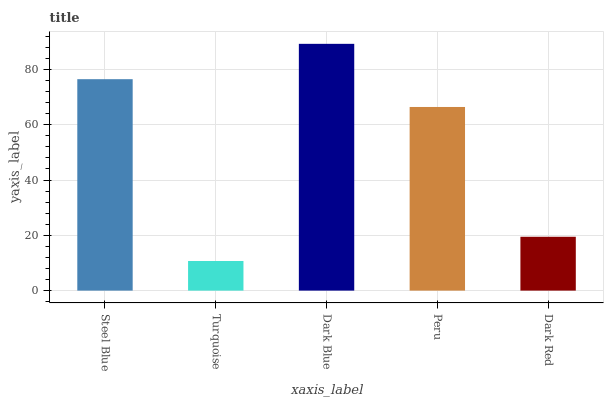Is Turquoise the minimum?
Answer yes or no. Yes. Is Dark Blue the maximum?
Answer yes or no. Yes. Is Dark Blue the minimum?
Answer yes or no. No. Is Turquoise the maximum?
Answer yes or no. No. Is Dark Blue greater than Turquoise?
Answer yes or no. Yes. Is Turquoise less than Dark Blue?
Answer yes or no. Yes. Is Turquoise greater than Dark Blue?
Answer yes or no. No. Is Dark Blue less than Turquoise?
Answer yes or no. No. Is Peru the high median?
Answer yes or no. Yes. Is Peru the low median?
Answer yes or no. Yes. Is Turquoise the high median?
Answer yes or no. No. Is Dark Blue the low median?
Answer yes or no. No. 